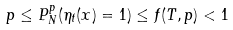Convert formula to latex. <formula><loc_0><loc_0><loc_500><loc_500>p \leq P ^ { p } _ { N } ( \eta _ { t } ( x ) = 1 ) \leq f ( T , p ) < 1</formula> 